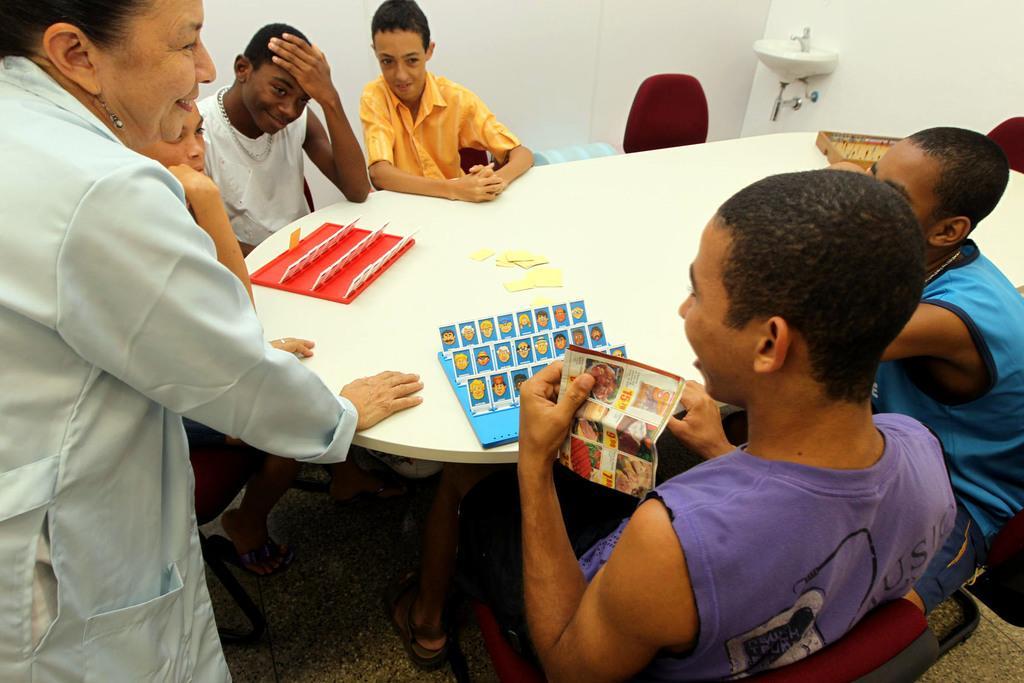Can you describe this image briefly? There are few men sitting on the chair at the table and on the right a woman is standing. We can see chairs,sink and wall in the picture. 